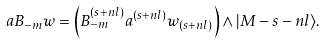Convert formula to latex. <formula><loc_0><loc_0><loc_500><loc_500>a B _ { - m } w = \left ( B _ { - m } ^ { ( s + n l ) } a ^ { ( s + n l ) } w _ { ( s + n l ) } \right ) \wedge | M - s - n l \rangle .</formula> 